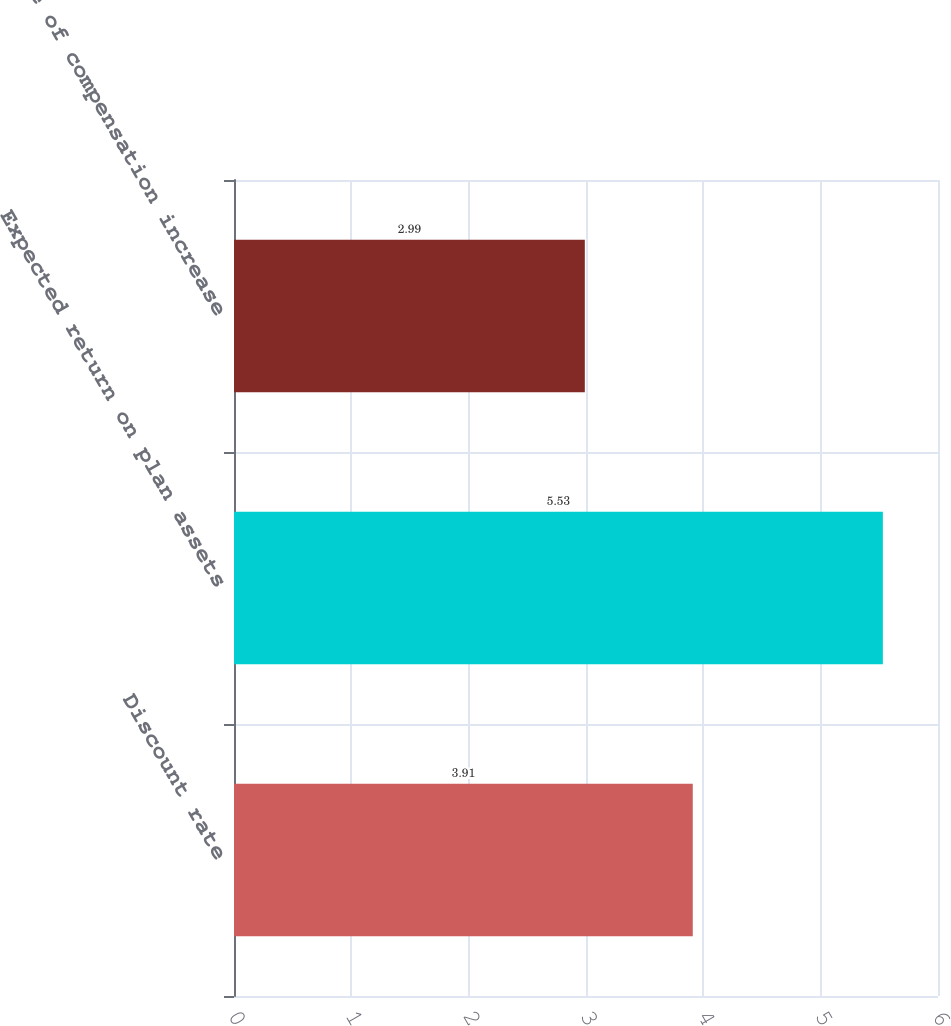Convert chart. <chart><loc_0><loc_0><loc_500><loc_500><bar_chart><fcel>Discount rate<fcel>Expected return on plan assets<fcel>Rate of compensation increase<nl><fcel>3.91<fcel>5.53<fcel>2.99<nl></chart> 